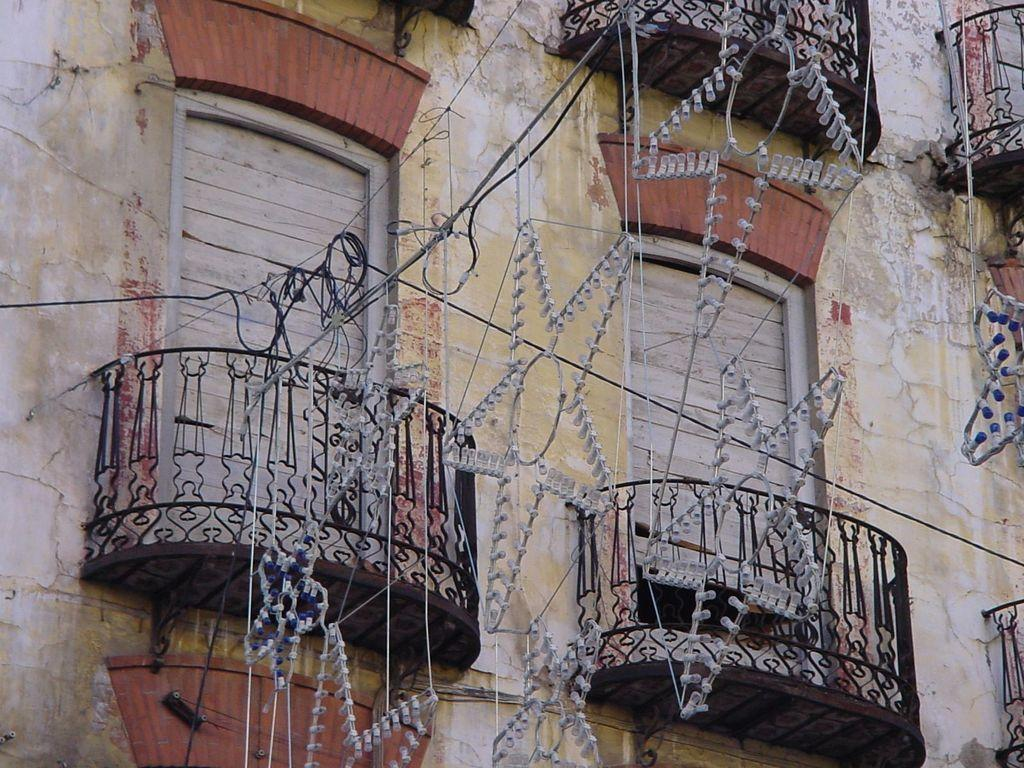What is the main feature in the image? There is a wall in the image. What is unique about the wall? The wall is decorated with lights. Are there any openings in the wall? Yes, there are doors in the middle of the image. What type of education can be seen being taught in the image? There is no indication of any educational activity in the image; it primarily features a wall with lights and doors. 